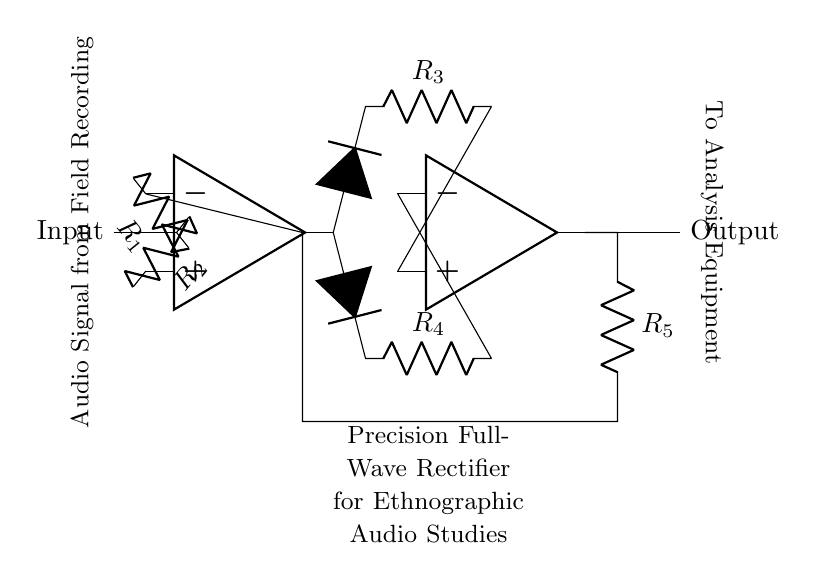What components are used in this circuit? The components visible in the diagram include two operational amplifiers, four resistors, and two diodes. The op-amps are labeled, and each resistor has a designated value as indicated.
Answer: Two operational amplifiers, four resistors, two diodes What is the purpose of the diodes in this circuit? The diodes in this full-wave rectifier circuit are used to allow current to flow in one direction only, thereby converting the AC audio signal into a DC signal. This action helps in accurately capturing the audio signal variations.
Answer: For rectification What type of rectifier is represented in this circuit? The circuit represents a precision full-wave rectifier, which means it can accurately convert both halves of the input audio signal into a usable DC output, preserving small signal details essential for audio processing.
Answer: Precision full-wave rectifier How many resistors are used in the feedback loops of the op-amps? There are two resistors (R3 and R4) that contribute to the feedback loops for each of the operational amplifiers, which is crucial for maintaining stability and gain control.
Answer: Two What does the label "Audio Signal from Field Recording" indicate? This label denotes the input to the rectifier system, specifically highlighting that the audio signal comes from ethnographic field recordings, which often have varying amplitudes that can benefit from precise rectification.
Answer: Audio input source What is the output of this rectifier circuit directed towards? The output is directed towards the analysis equipment, which implies that the rectified audio signal will be processed or analyzed further, likely for study in an ethnographic context.
Answer: Analysis equipment 